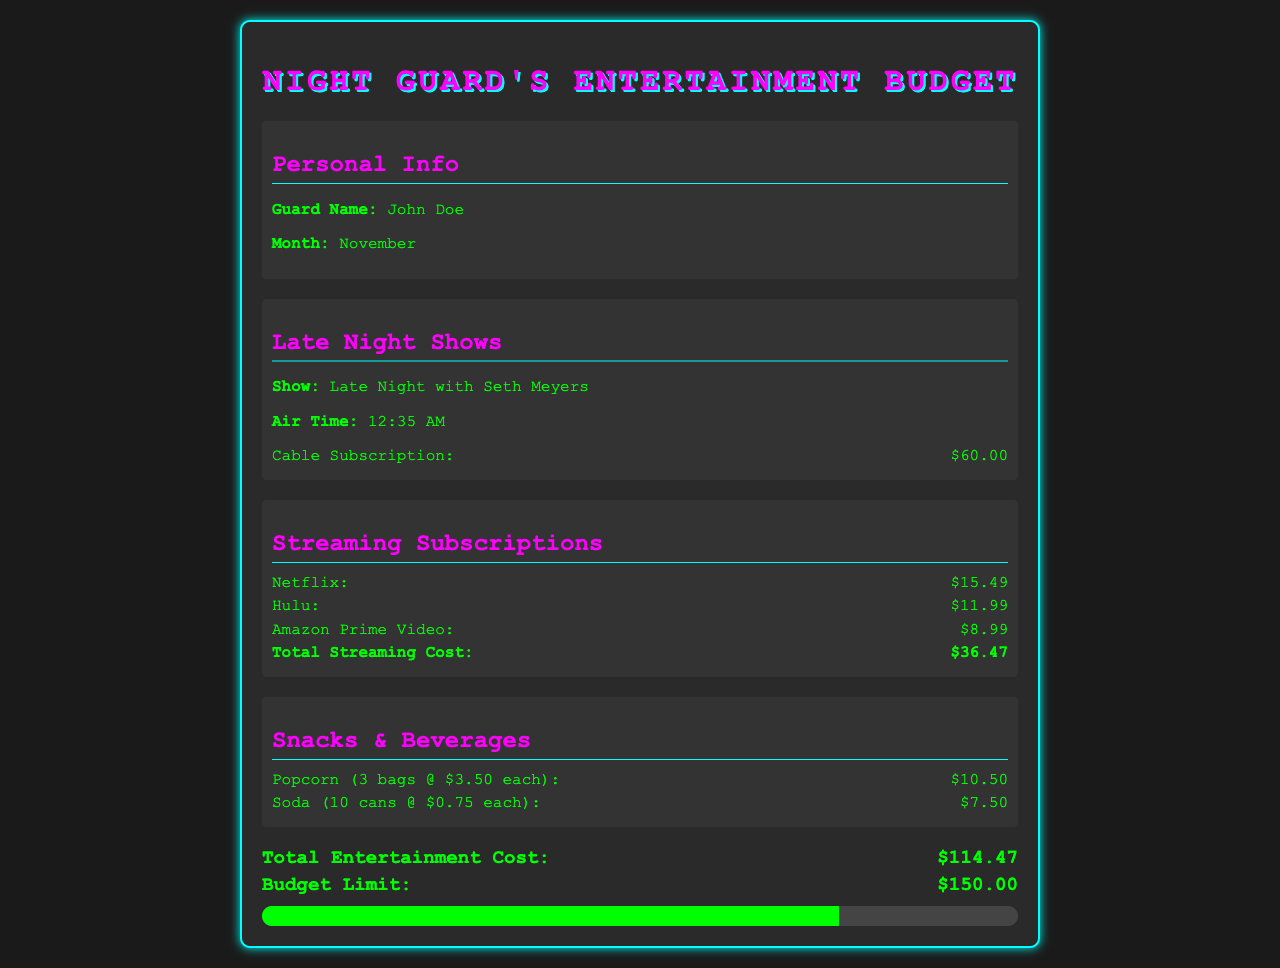What is the name of the guard? The guard's name is mentioned in the personal information section of the document as John Doe.
Answer: John Doe What is the cable subscription cost? The cable subscription cost is specified under the Late Night Shows section as $60.00.
Answer: $60.00 What is the total cost of streaming subscriptions? The total streaming cost is calculated by summing the individual streaming subscription costs, which is provided in the Streaming Subscriptions section.
Answer: $36.47 How much is spent on popcorn? The expense for popcorn is detailed in the Snacks & Beverages section as $10.50 for 3 bags.
Answer: $10.50 What is the total entertainment cost for the month? The total entertainment cost is calculated and listed in the summary section of the document as $114.47.
Answer: $114.47 What is the budget limit for entertainment? The budget limit is listed in the summary section and specifies the maximum allowable spend for the month.
Answer: $150.00 Which late-night show is featured? The document specifies the late-night show under the Late Night Shows section as Late Night with Seth Meyers.
Answer: Late Night with Seth Meyers What is the air time for the late-night show? The air time for the late-night show is explicitly mentioned as 12:35 AM in the Late Night Shows section.
Answer: 12:35 AM How many cans of soda are included in the snack expenses? The number of soda cans is detailed as 10 cans for $7.50 in the Snacks & Beverages section.
Answer: 10 cans 